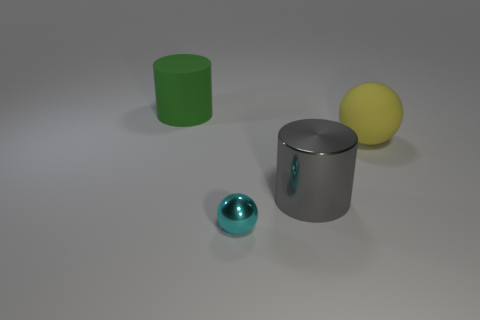Are there any large matte things of the same color as the metal cylinder?
Your response must be concise. No. Are any big gray metallic objects visible?
Your answer should be compact. Yes. There is a thing behind the matte ball; is its size the same as the big metallic thing?
Make the answer very short. Yes. Is the number of big balls less than the number of purple objects?
Provide a short and direct response. No. The tiny object in front of the large cylinder that is behind the yellow ball on the right side of the big green cylinder is what shape?
Your answer should be very brief. Sphere. Is there another cylinder made of the same material as the large gray cylinder?
Your answer should be compact. No. There is a large object in front of the yellow sphere; is its color the same as the large matte thing on the right side of the green cylinder?
Ensure brevity in your answer.  No. Is the number of shiny objects that are behind the cyan thing less than the number of large red rubber balls?
Make the answer very short. No. What number of objects are either gray metallic things or big cylinders that are to the right of the small sphere?
Make the answer very short. 1. There is a big ball that is made of the same material as the large green object; what color is it?
Your response must be concise. Yellow. 